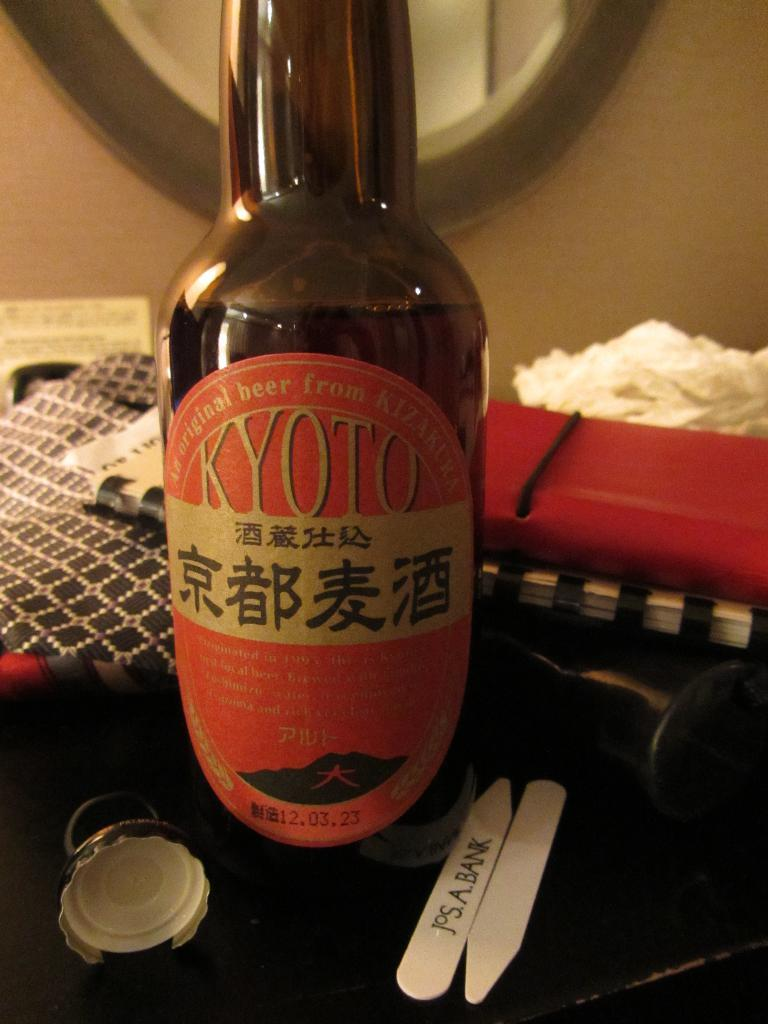<image>
Create a compact narrative representing the image presented. A bottle of Kyoto japanese beer on a table. 